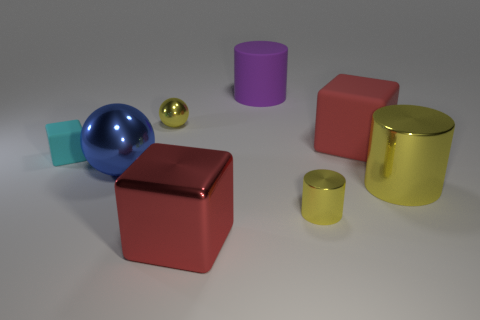There is a tiny object that is behind the large red matte object; is its color the same as the big cylinder that is in front of the tiny cyan thing?
Offer a terse response. Yes. There is a rubber object that is left of the big purple rubber cylinder; how many yellow metallic things are in front of it?
Ensure brevity in your answer.  2. Are any green metallic things visible?
Provide a short and direct response. No. How many other objects are the same color as the small shiny cylinder?
Make the answer very short. 2. Are there fewer big blue metal things than red things?
Keep it short and to the point. Yes. What is the shape of the red object that is behind the metallic cylinder to the right of the small yellow shiny cylinder?
Provide a succinct answer. Cube. There is a big blue object; are there any small cyan rubber cubes in front of it?
Your answer should be compact. No. The metallic cylinder that is the same size as the red matte object is what color?
Make the answer very short. Yellow. What number of blocks have the same material as the yellow ball?
Provide a succinct answer. 1. How many other objects are there of the same size as the cyan rubber block?
Your response must be concise. 2. 